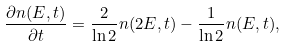Convert formula to latex. <formula><loc_0><loc_0><loc_500><loc_500>\frac { \partial n ( E , t ) } { \partial t } = \frac { 2 } { \ln 2 } n ( 2 E , t ) - \frac { 1 } { \ln 2 } n ( E , t ) ,</formula> 